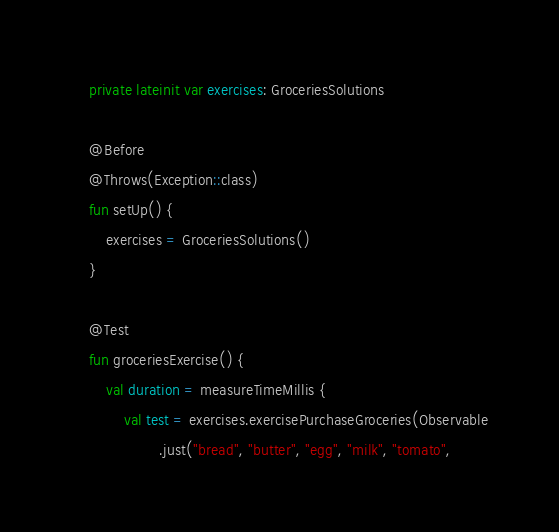Convert code to text. <code><loc_0><loc_0><loc_500><loc_500><_Kotlin_>
    private lateinit var exercises: GroceriesSolutions

    @Before
    @Throws(Exception::class)
    fun setUp() {
        exercises = GroceriesSolutions()
    }

    @Test
    fun groceriesExercise() {
        val duration = measureTimeMillis {
            val test = exercises.exercisePurchaseGroceries(Observable
                    .just("bread", "butter", "egg", "milk", "tomato",</code> 